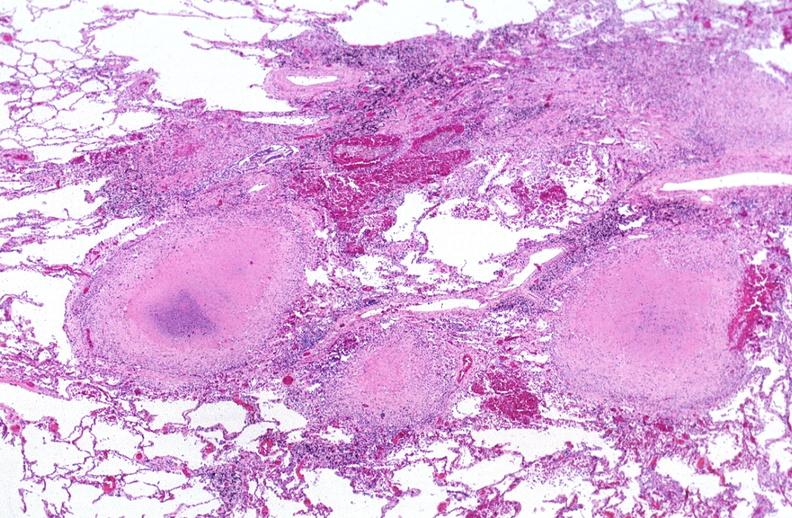does this image show lung, mycobacterium tuberculosis, granulomas and giant cells?
Answer the question using a single word or phrase. Yes 